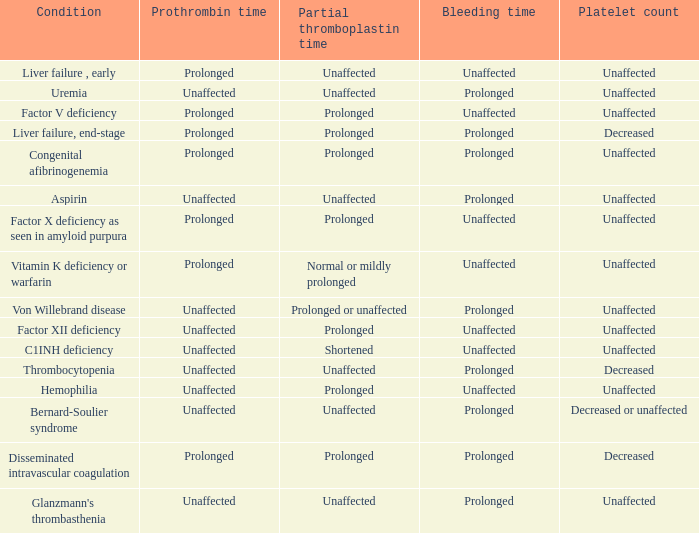Which Prothrombin time has a Platelet count of unaffected, and a Bleeding time of unaffected, and a Partial thromboplastin time of normal or mildly prolonged? Prolonged. 